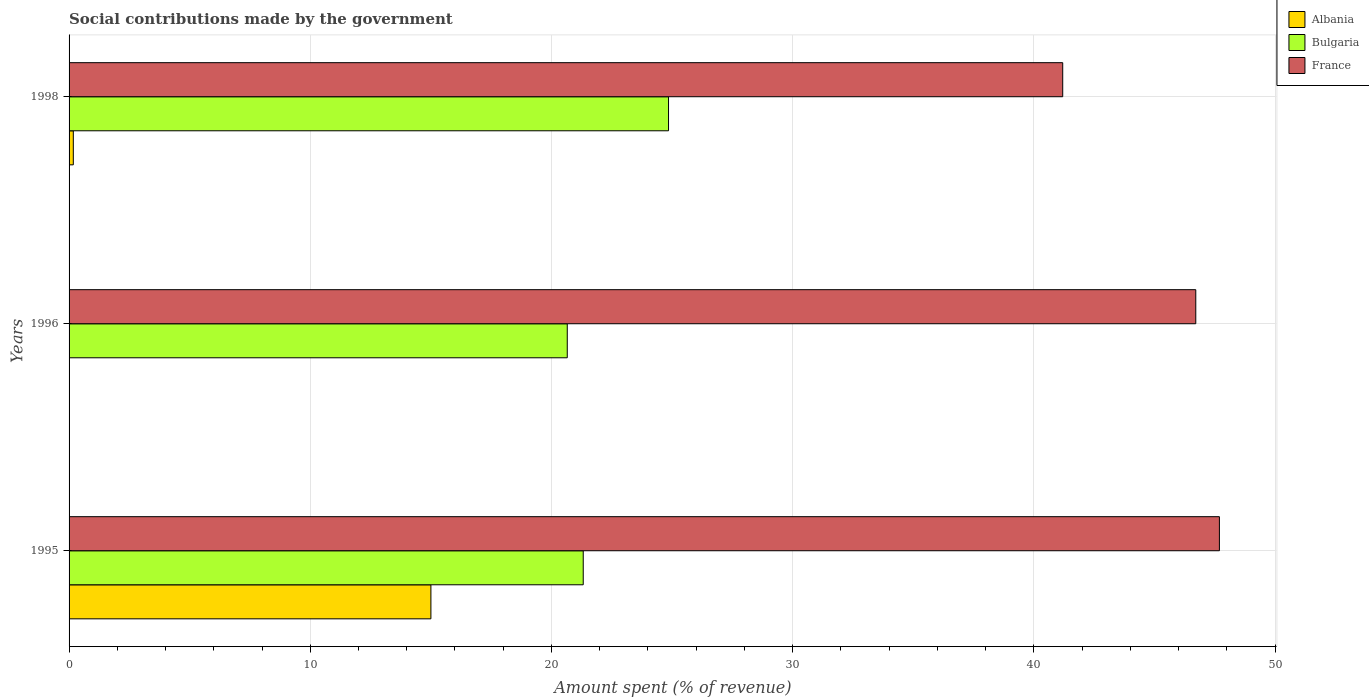Are the number of bars per tick equal to the number of legend labels?
Your answer should be very brief. Yes. How many bars are there on the 2nd tick from the top?
Give a very brief answer. 3. What is the amount spent (in %) on social contributions in Albania in 1995?
Your response must be concise. 15. Across all years, what is the maximum amount spent (in %) on social contributions in Albania?
Make the answer very short. 15. Across all years, what is the minimum amount spent (in %) on social contributions in Albania?
Your answer should be very brief. 5.27984526251892e-6. What is the total amount spent (in %) on social contributions in Albania in the graph?
Your response must be concise. 15.18. What is the difference between the amount spent (in %) on social contributions in Bulgaria in 1995 and that in 1998?
Provide a succinct answer. -3.54. What is the difference between the amount spent (in %) on social contributions in France in 1995 and the amount spent (in %) on social contributions in Bulgaria in 1998?
Your answer should be very brief. 22.84. What is the average amount spent (in %) on social contributions in France per year?
Your answer should be very brief. 45.2. In the year 1995, what is the difference between the amount spent (in %) on social contributions in Albania and amount spent (in %) on social contributions in France?
Your answer should be compact. -32.69. In how many years, is the amount spent (in %) on social contributions in Albania greater than 2 %?
Offer a terse response. 1. What is the ratio of the amount spent (in %) on social contributions in Albania in 1995 to that in 1996?
Provide a succinct answer. 2.84e+06. Is the amount spent (in %) on social contributions in Albania in 1995 less than that in 1996?
Offer a very short reply. No. Is the difference between the amount spent (in %) on social contributions in Albania in 1996 and 1998 greater than the difference between the amount spent (in %) on social contributions in France in 1996 and 1998?
Provide a short and direct response. No. What is the difference between the highest and the second highest amount spent (in %) on social contributions in Bulgaria?
Your answer should be compact. 3.54. What is the difference between the highest and the lowest amount spent (in %) on social contributions in Albania?
Give a very brief answer. 15. In how many years, is the amount spent (in %) on social contributions in Bulgaria greater than the average amount spent (in %) on social contributions in Bulgaria taken over all years?
Provide a short and direct response. 1. What does the 3rd bar from the top in 1996 represents?
Provide a short and direct response. Albania. Is it the case that in every year, the sum of the amount spent (in %) on social contributions in Albania and amount spent (in %) on social contributions in Bulgaria is greater than the amount spent (in %) on social contributions in France?
Offer a very short reply. No. Are all the bars in the graph horizontal?
Give a very brief answer. Yes. How many years are there in the graph?
Ensure brevity in your answer.  3. Are the values on the major ticks of X-axis written in scientific E-notation?
Ensure brevity in your answer.  No. Does the graph contain any zero values?
Provide a succinct answer. No. Where does the legend appear in the graph?
Keep it short and to the point. Top right. How many legend labels are there?
Your response must be concise. 3. What is the title of the graph?
Offer a very short reply. Social contributions made by the government. Does "Bermuda" appear as one of the legend labels in the graph?
Keep it short and to the point. No. What is the label or title of the X-axis?
Give a very brief answer. Amount spent (% of revenue). What is the Amount spent (% of revenue) in Albania in 1995?
Your answer should be very brief. 15. What is the Amount spent (% of revenue) in Bulgaria in 1995?
Provide a short and direct response. 21.32. What is the Amount spent (% of revenue) of France in 1995?
Make the answer very short. 47.69. What is the Amount spent (% of revenue) in Albania in 1996?
Make the answer very short. 5.27984526251892e-6. What is the Amount spent (% of revenue) in Bulgaria in 1996?
Provide a short and direct response. 20.66. What is the Amount spent (% of revenue) in France in 1996?
Your answer should be compact. 46.71. What is the Amount spent (% of revenue) of Albania in 1998?
Your answer should be compact. 0.18. What is the Amount spent (% of revenue) of Bulgaria in 1998?
Your answer should be very brief. 24.85. What is the Amount spent (% of revenue) of France in 1998?
Ensure brevity in your answer.  41.2. Across all years, what is the maximum Amount spent (% of revenue) in Albania?
Your response must be concise. 15. Across all years, what is the maximum Amount spent (% of revenue) in Bulgaria?
Give a very brief answer. 24.85. Across all years, what is the maximum Amount spent (% of revenue) in France?
Your response must be concise. 47.69. Across all years, what is the minimum Amount spent (% of revenue) of Albania?
Keep it short and to the point. 5.27984526251892e-6. Across all years, what is the minimum Amount spent (% of revenue) of Bulgaria?
Make the answer very short. 20.66. Across all years, what is the minimum Amount spent (% of revenue) in France?
Your answer should be very brief. 41.2. What is the total Amount spent (% of revenue) in Albania in the graph?
Offer a terse response. 15.18. What is the total Amount spent (% of revenue) of Bulgaria in the graph?
Provide a short and direct response. 66.83. What is the total Amount spent (% of revenue) in France in the graph?
Give a very brief answer. 135.6. What is the difference between the Amount spent (% of revenue) in Albania in 1995 and that in 1996?
Ensure brevity in your answer.  15. What is the difference between the Amount spent (% of revenue) of Bulgaria in 1995 and that in 1996?
Your answer should be very brief. 0.66. What is the difference between the Amount spent (% of revenue) in France in 1995 and that in 1996?
Provide a short and direct response. 0.98. What is the difference between the Amount spent (% of revenue) of Albania in 1995 and that in 1998?
Your answer should be very brief. 14.83. What is the difference between the Amount spent (% of revenue) of Bulgaria in 1995 and that in 1998?
Ensure brevity in your answer.  -3.54. What is the difference between the Amount spent (% of revenue) of France in 1995 and that in 1998?
Offer a very short reply. 6.5. What is the difference between the Amount spent (% of revenue) of Albania in 1996 and that in 1998?
Give a very brief answer. -0.18. What is the difference between the Amount spent (% of revenue) of Bulgaria in 1996 and that in 1998?
Ensure brevity in your answer.  -4.2. What is the difference between the Amount spent (% of revenue) in France in 1996 and that in 1998?
Your answer should be very brief. 5.52. What is the difference between the Amount spent (% of revenue) of Albania in 1995 and the Amount spent (% of revenue) of Bulgaria in 1996?
Keep it short and to the point. -5.65. What is the difference between the Amount spent (% of revenue) of Albania in 1995 and the Amount spent (% of revenue) of France in 1996?
Provide a short and direct response. -31.71. What is the difference between the Amount spent (% of revenue) in Bulgaria in 1995 and the Amount spent (% of revenue) in France in 1996?
Ensure brevity in your answer.  -25.4. What is the difference between the Amount spent (% of revenue) in Albania in 1995 and the Amount spent (% of revenue) in Bulgaria in 1998?
Keep it short and to the point. -9.85. What is the difference between the Amount spent (% of revenue) of Albania in 1995 and the Amount spent (% of revenue) of France in 1998?
Give a very brief answer. -26.19. What is the difference between the Amount spent (% of revenue) in Bulgaria in 1995 and the Amount spent (% of revenue) in France in 1998?
Your answer should be compact. -19.88. What is the difference between the Amount spent (% of revenue) of Albania in 1996 and the Amount spent (% of revenue) of Bulgaria in 1998?
Provide a succinct answer. -24.85. What is the difference between the Amount spent (% of revenue) of Albania in 1996 and the Amount spent (% of revenue) of France in 1998?
Your answer should be very brief. -41.2. What is the difference between the Amount spent (% of revenue) of Bulgaria in 1996 and the Amount spent (% of revenue) of France in 1998?
Provide a short and direct response. -20.54. What is the average Amount spent (% of revenue) in Albania per year?
Keep it short and to the point. 5.06. What is the average Amount spent (% of revenue) in Bulgaria per year?
Your answer should be very brief. 22.28. What is the average Amount spent (% of revenue) of France per year?
Your answer should be compact. 45.2. In the year 1995, what is the difference between the Amount spent (% of revenue) of Albania and Amount spent (% of revenue) of Bulgaria?
Your response must be concise. -6.32. In the year 1995, what is the difference between the Amount spent (% of revenue) of Albania and Amount spent (% of revenue) of France?
Your response must be concise. -32.69. In the year 1995, what is the difference between the Amount spent (% of revenue) of Bulgaria and Amount spent (% of revenue) of France?
Provide a short and direct response. -26.38. In the year 1996, what is the difference between the Amount spent (% of revenue) in Albania and Amount spent (% of revenue) in Bulgaria?
Give a very brief answer. -20.66. In the year 1996, what is the difference between the Amount spent (% of revenue) in Albania and Amount spent (% of revenue) in France?
Your response must be concise. -46.71. In the year 1996, what is the difference between the Amount spent (% of revenue) in Bulgaria and Amount spent (% of revenue) in France?
Your response must be concise. -26.06. In the year 1998, what is the difference between the Amount spent (% of revenue) in Albania and Amount spent (% of revenue) in Bulgaria?
Ensure brevity in your answer.  -24.68. In the year 1998, what is the difference between the Amount spent (% of revenue) of Albania and Amount spent (% of revenue) of France?
Give a very brief answer. -41.02. In the year 1998, what is the difference between the Amount spent (% of revenue) in Bulgaria and Amount spent (% of revenue) in France?
Ensure brevity in your answer.  -16.34. What is the ratio of the Amount spent (% of revenue) of Albania in 1995 to that in 1996?
Offer a very short reply. 2.84e+06. What is the ratio of the Amount spent (% of revenue) of Bulgaria in 1995 to that in 1996?
Provide a short and direct response. 1.03. What is the ratio of the Amount spent (% of revenue) of France in 1995 to that in 1996?
Ensure brevity in your answer.  1.02. What is the ratio of the Amount spent (% of revenue) in Albania in 1995 to that in 1998?
Your answer should be very brief. 85.37. What is the ratio of the Amount spent (% of revenue) of Bulgaria in 1995 to that in 1998?
Offer a very short reply. 0.86. What is the ratio of the Amount spent (% of revenue) in France in 1995 to that in 1998?
Your answer should be compact. 1.16. What is the ratio of the Amount spent (% of revenue) of Albania in 1996 to that in 1998?
Ensure brevity in your answer.  0. What is the ratio of the Amount spent (% of revenue) in Bulgaria in 1996 to that in 1998?
Make the answer very short. 0.83. What is the ratio of the Amount spent (% of revenue) of France in 1996 to that in 1998?
Provide a short and direct response. 1.13. What is the difference between the highest and the second highest Amount spent (% of revenue) in Albania?
Your response must be concise. 14.83. What is the difference between the highest and the second highest Amount spent (% of revenue) of Bulgaria?
Offer a terse response. 3.54. What is the difference between the highest and the second highest Amount spent (% of revenue) in France?
Offer a terse response. 0.98. What is the difference between the highest and the lowest Amount spent (% of revenue) of Albania?
Your answer should be very brief. 15. What is the difference between the highest and the lowest Amount spent (% of revenue) of Bulgaria?
Your answer should be very brief. 4.2. What is the difference between the highest and the lowest Amount spent (% of revenue) in France?
Provide a short and direct response. 6.5. 